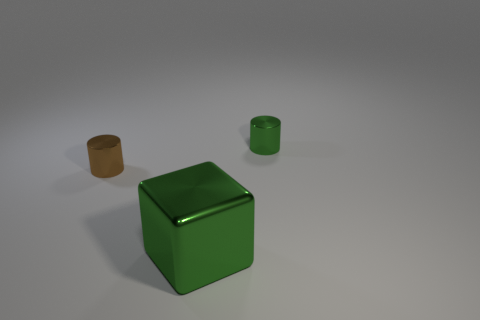What number of other objects are the same color as the large block?
Ensure brevity in your answer.  1. The large shiny object that is in front of the small green cylinder has what shape?
Keep it short and to the point. Cube. What number of things are either tiny gray metallic blocks or large green cubes?
Offer a terse response. 1. Is the size of the green metallic cylinder the same as the metallic cylinder on the left side of the cube?
Offer a very short reply. Yes. How many other objects are the same material as the small brown cylinder?
Your answer should be compact. 2. How many things are tiny metallic objects to the left of the big metal block or shiny objects that are on the right side of the large object?
Provide a succinct answer. 2. What is the material of the other thing that is the same shape as the brown thing?
Offer a very short reply. Metal. Are there any small gray metallic cylinders?
Keep it short and to the point. No. There is a shiny thing that is behind the large green metallic thing and in front of the green metallic cylinder; how big is it?
Offer a terse response. Small. What shape is the large thing?
Your answer should be very brief. Cube. 